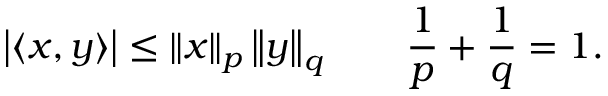<formula> <loc_0><loc_0><loc_500><loc_500>\left | \langle x , y \rangle \right | \leq \left \| x \right \| _ { p } \left \| y \right \| _ { q } \quad { \frac { 1 } { p } } + { \frac { 1 } { q } } = 1 .</formula> 